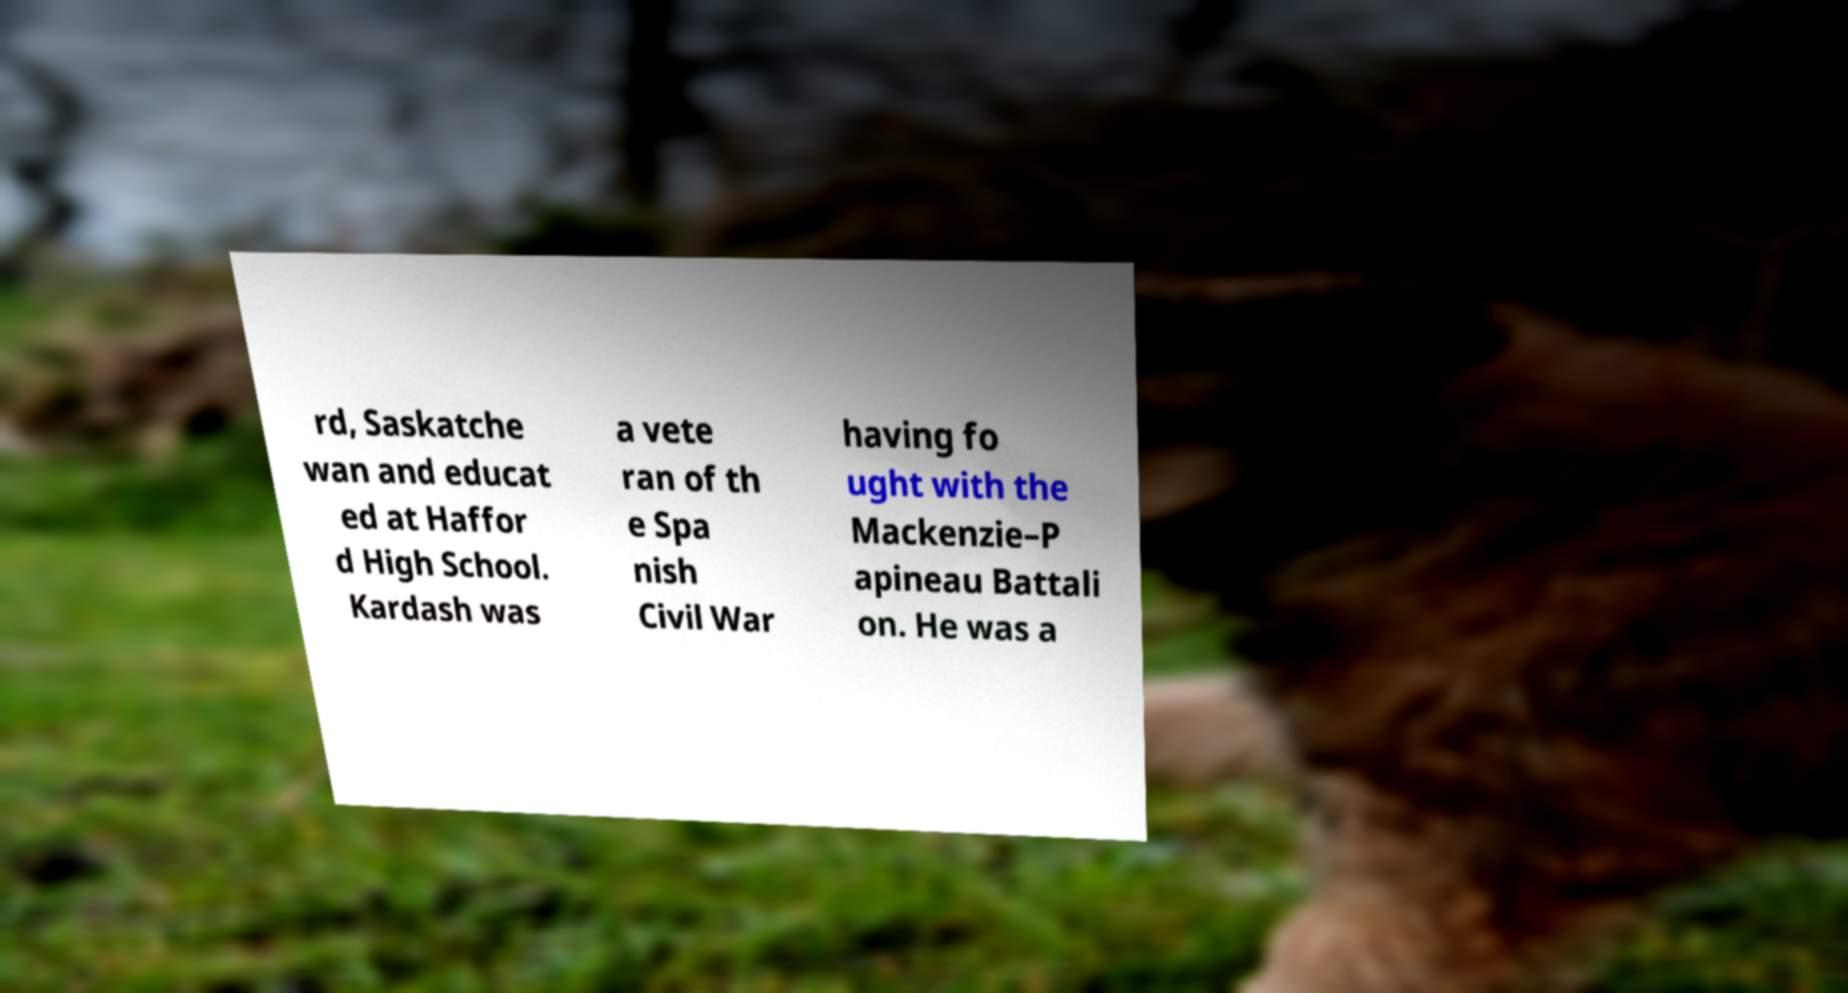Could you assist in decoding the text presented in this image and type it out clearly? rd, Saskatche wan and educat ed at Haffor d High School. Kardash was a vete ran of th e Spa nish Civil War having fo ught with the Mackenzie–P apineau Battali on. He was a 